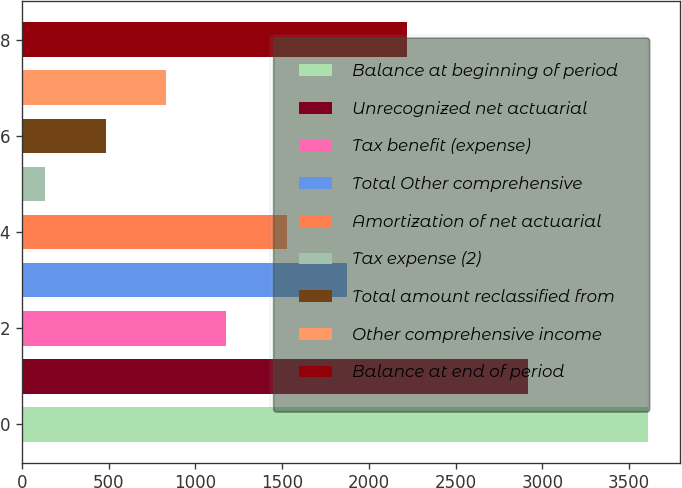Convert chart to OTSL. <chart><loc_0><loc_0><loc_500><loc_500><bar_chart><fcel>Balance at beginning of period<fcel>Unrecognized net actuarial<fcel>Tax benefit (expense)<fcel>Total Other comprehensive<fcel>Amortization of net actuarial<fcel>Tax expense (2)<fcel>Total amount reclassified from<fcel>Other comprehensive income<fcel>Balance at end of period<nl><fcel>3611<fcel>2916<fcel>1178.5<fcel>1873.5<fcel>1526<fcel>136<fcel>483.5<fcel>831<fcel>2221<nl></chart> 